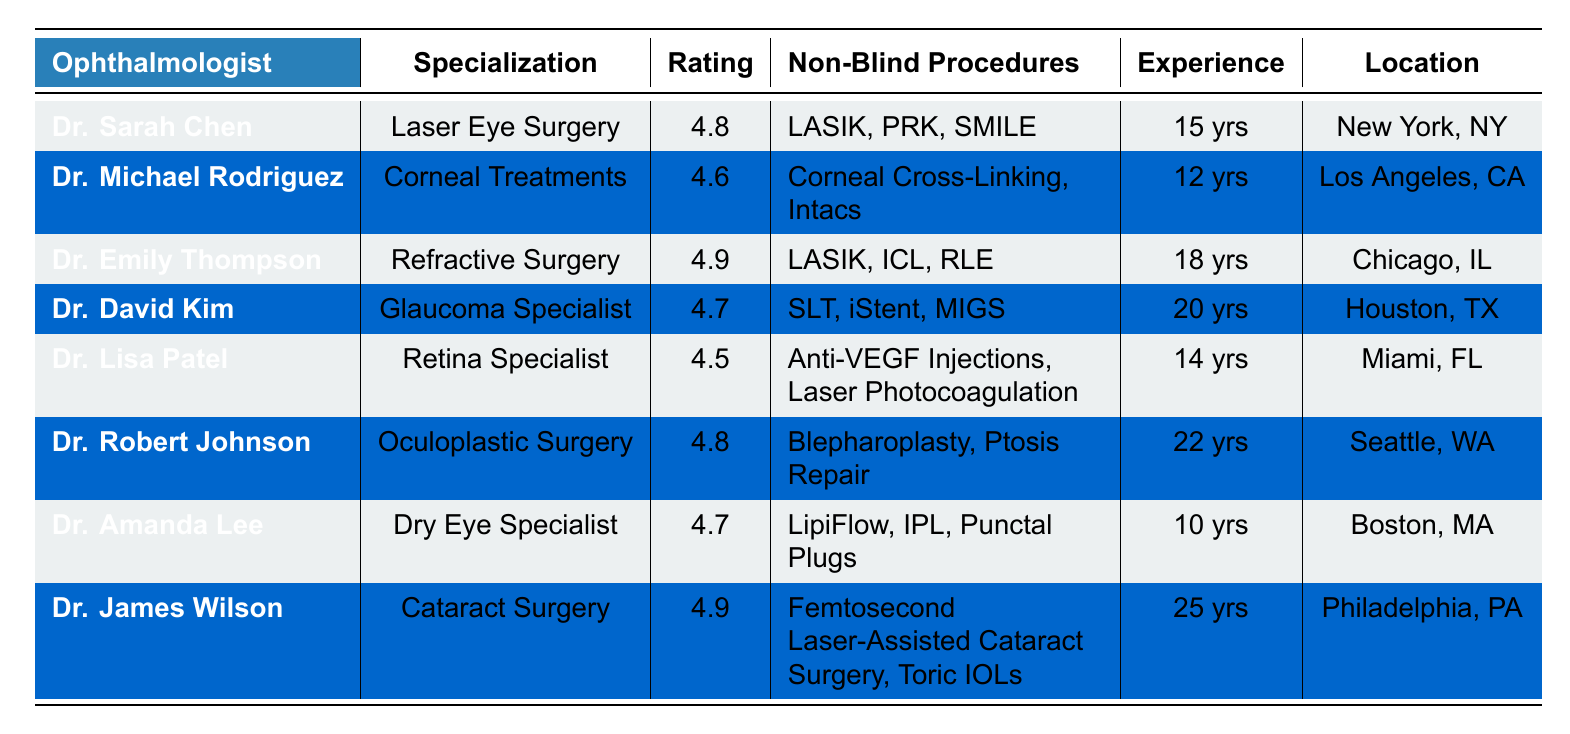What is the highest patient satisfaction rating among the ophthalmologists listed? The patient satisfaction ratings are: 4.8, 4.6, 4.9, 4.7, 4.5, 4.8, 4.7, and 4.9. The highest rating is 4.9, which appears for Dr. Emily Thompson and Dr. James Wilson.
Answer: 4.9 Which ophthalmologist has the most years of experience? The years of experience listed are: 15, 12, 18, 20, 14, 22, 10, and 25. The most years of experience is 25 years, which belongs to Dr. James Wilson.
Answer: Dr. James Wilson Are there any ophthalmologists who specialize in Laser Eye Surgery? The specialization for each ophthalmologist includes Laser Eye Surgery, Corneal Treatments, Refractive Surgery, Glaucoma Specialist, Retina Specialist, Oculoplastic Surgery, Dry Eye Specialist, and Cataract Surgery. Dr. Sarah Chen specializes in Laser Eye Surgery.
Answer: Yes What is the average patient satisfaction rating for the listed ophthalmologists? The patient satisfaction ratings are: 4.8, 4.6, 4.9, 4.7, 4.5, 4.8, 4.7, and 4.9. To calculate the average, sum these ratings (4.8 + 4.6 + 4.9 + 4.7 + 4.5 + 4.8 + 4.7 + 4.9 = 38.9) and then divide by the number of data points (8). The average rating is 38.9 / 8 = 4.86.
Answer: 4.86 Which city has the ophthalmologist with the most non-blind procedures offered? The ophthalmologists listed have the following non-blind procedures: Dr. Sarah Chen (LASIK, PRK, SMILE), Dr. Michael Rodriguez (Corneal Cross-Linking, Intacs), Dr. Emily Thompson (LASIK, ICL, RLE), Dr. David Kim (SLT, iStent, MIGS), Dr. Lisa Patel (Anti-VEGF Injections, Laser Photocoagulation), Dr. Robert Johnson (Blepharoplasty, Ptosis Repair), Dr. Amanda Lee (LipiFlow, IPL, Punctal Plugs), and Dr. James Wilson (Femtosecond Laser-Assisted Cataract Surgery, Toric IOLs). The highest count of procedures is offered by Dr. James Wilson in Philadelphia, PA with 2 procedures.
Answer: Philadelphia, PA Are there any ophthalmologists with a patient satisfaction rating of 4.5 or lower? The ratings of the ophthalmologists are listed, with Dr. Lisa Patel having a rating of 4.5 as her score. All other ratings are higher than 4.5 (4.8, 4.6, 4.9, 4.7, 4.8, and 4.7).
Answer: Yes, Dr. Lisa Patel has a rating of 4.5 What is the difference in years of experience between the least and most experienced ophthalmologists? The least experienced ophthalmologist is Dr. Amanda Lee with 10 years of experience, and the most experienced is Dr. James Wilson with 25 years. To find the difference, subtract: 25 - 10 = 15 years.
Answer: 15 years 